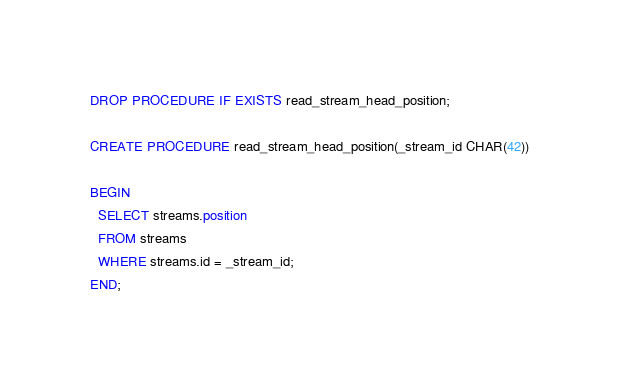Convert code to text. <code><loc_0><loc_0><loc_500><loc_500><_SQL_>DROP PROCEDURE IF EXISTS read_stream_head_position;

CREATE PROCEDURE read_stream_head_position(_stream_id CHAR(42))

BEGIN
  SELECT streams.position
  FROM streams
  WHERE streams.id = _stream_id;
END;</code> 